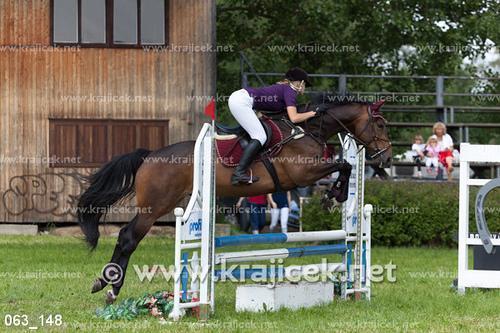How many horizontal bars are in the hurdle?
Give a very brief answer. 3. How many panes are in the upper window?
Give a very brief answer. 4. 